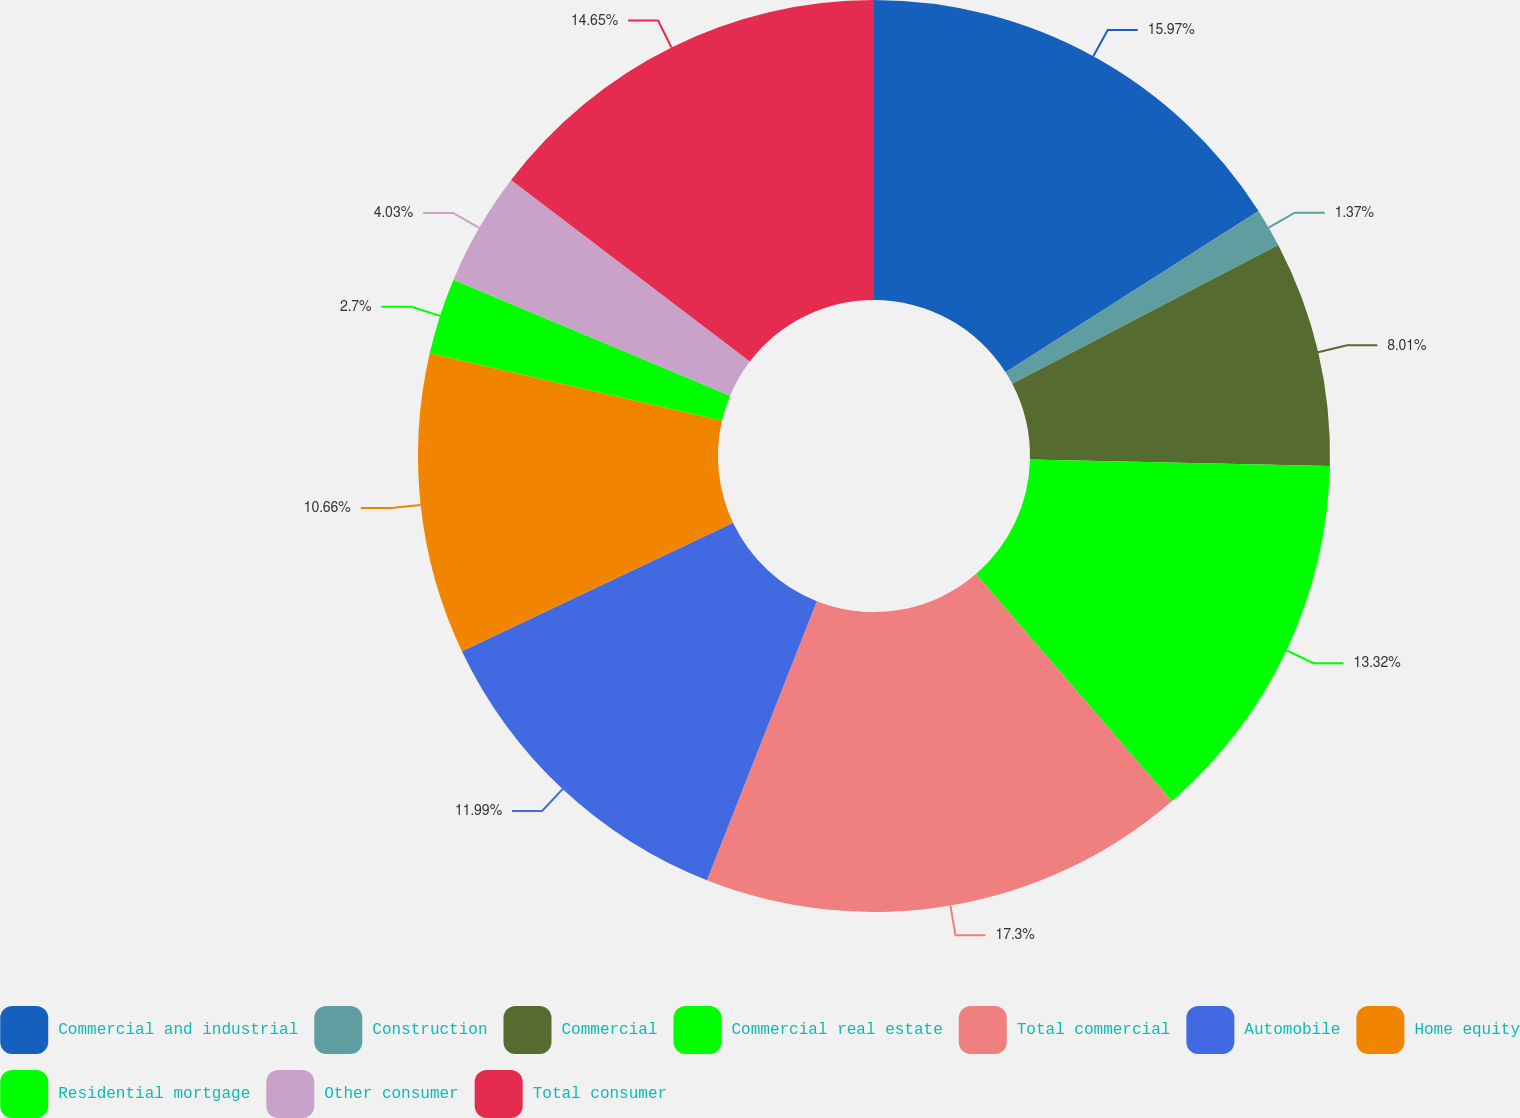<chart> <loc_0><loc_0><loc_500><loc_500><pie_chart><fcel>Commercial and industrial<fcel>Construction<fcel>Commercial<fcel>Commercial real estate<fcel>Total commercial<fcel>Automobile<fcel>Home equity<fcel>Residential mortgage<fcel>Other consumer<fcel>Total consumer<nl><fcel>15.97%<fcel>1.37%<fcel>8.01%<fcel>13.32%<fcel>17.3%<fcel>11.99%<fcel>10.66%<fcel>2.7%<fcel>4.03%<fcel>14.65%<nl></chart> 